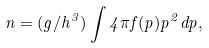<formula> <loc_0><loc_0><loc_500><loc_500>n = ( g / h ^ { 3 } ) \int 4 \pi f ( p ) p ^ { 2 } d p ,</formula> 